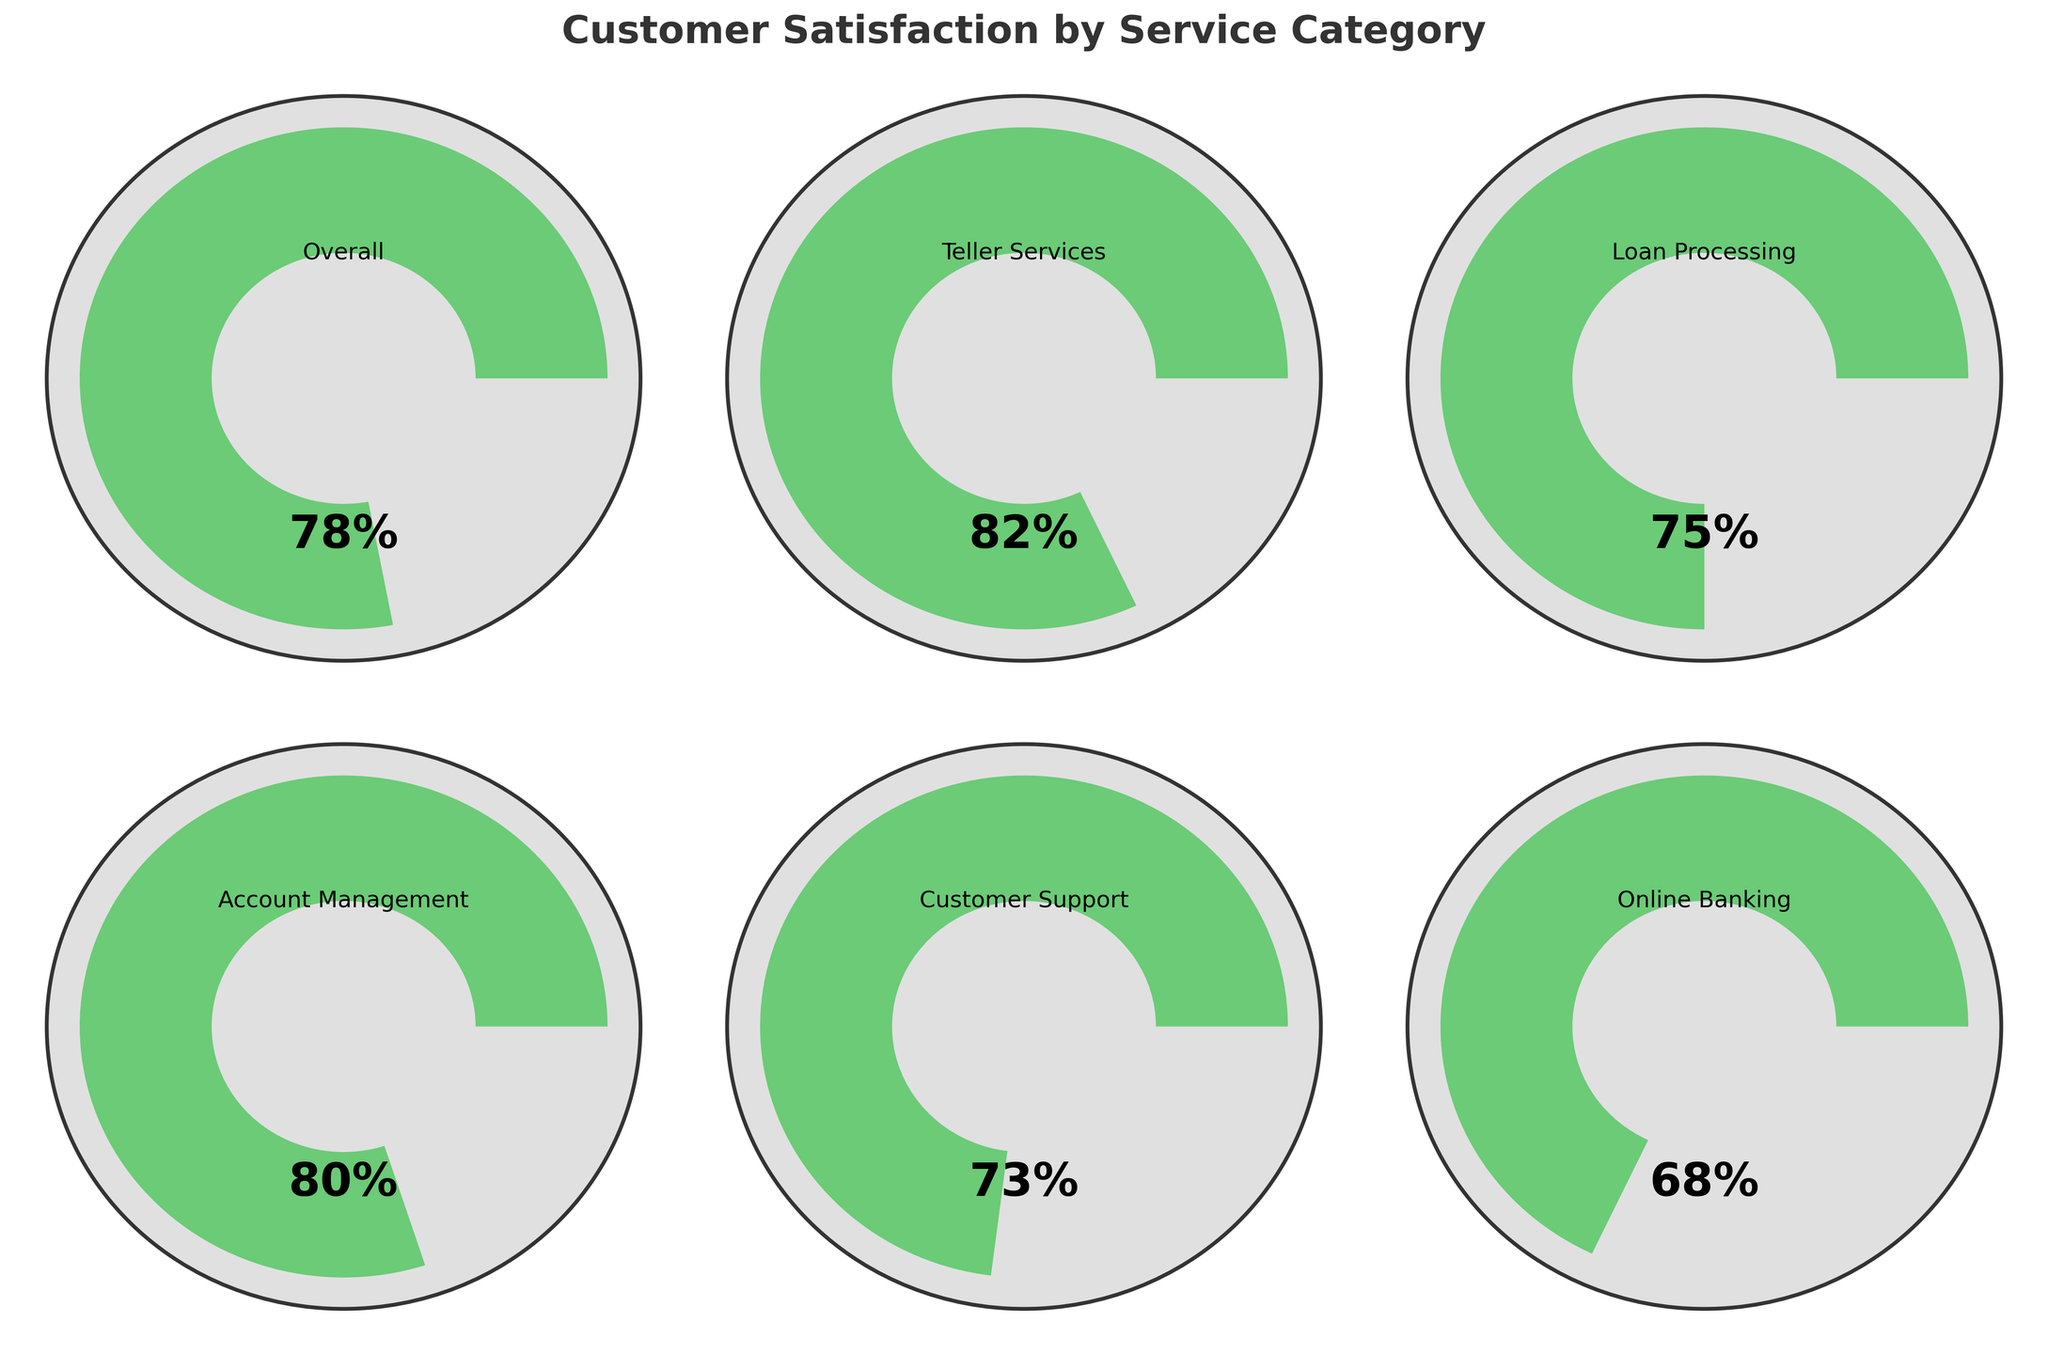What is the title of the figure? The title of the figure is displayed prominently at the top in bold font, it says "Customer Satisfaction by Service Category".
Answer: Customer Satisfaction by Service Category Which service category has the highest satisfaction level? The figure contains multiple gauge charts, each representing a service category with its satisfaction level. The "Teller Services" category shows the highest satisfaction level at 82%.
Answer: Teller Services What is the satisfaction level for Online Banking? The gauge chart for Online Banking shows the satisfaction level value inside the gauge. It is marked as 68%.
Answer: 68% How many service categories are represented in the figure? There are six gauge charts, each representing a different service category: Overall, Teller Services, Loan Processing, Account Management, Customer Support, and Online Banking.
Answer: 6 Which two service categories have the closest satisfaction levels? Observing the satisfaction levels in the gauge charts, "Loan Processing" with 75% and "Customer Support" with 73% are the closest in values. The difference is only 2%.
Answer: Loan Processing and Customer Support What is the color indicating the satisfaction level for Account Management? The gauge chart for "Account Management" shows a satisfaction level of 80%. The color associated with this level, in line with the described color scheme, should be within the range and defaults to a moderate green hue.
Answer: Green What is the average satisfaction level of all categories combined? The satisfaction levels for the six categories are: 78, 82, 75, 80, 73, 68. First, sum these values: 78 + 82 + 75 + 80 + 73 + 68 = 456. Divide by the number of categories which is 6. So, 456 / 6 = 76.
Answer: 76 Which service category has the lowest satisfaction level, and what is it? The gauge chart for "Online Banking" shows the lowest satisfaction level at 68%.
Answer: Online Banking, 68% How much higher is the satisfaction level of Teller Services compared to Online Banking? The satisfaction level for "Teller Services" is 82% and for "Online Banking" is 68%. Subtract 68 from 82 to find the difference. 82 - 68 = 14.
Answer: 14 